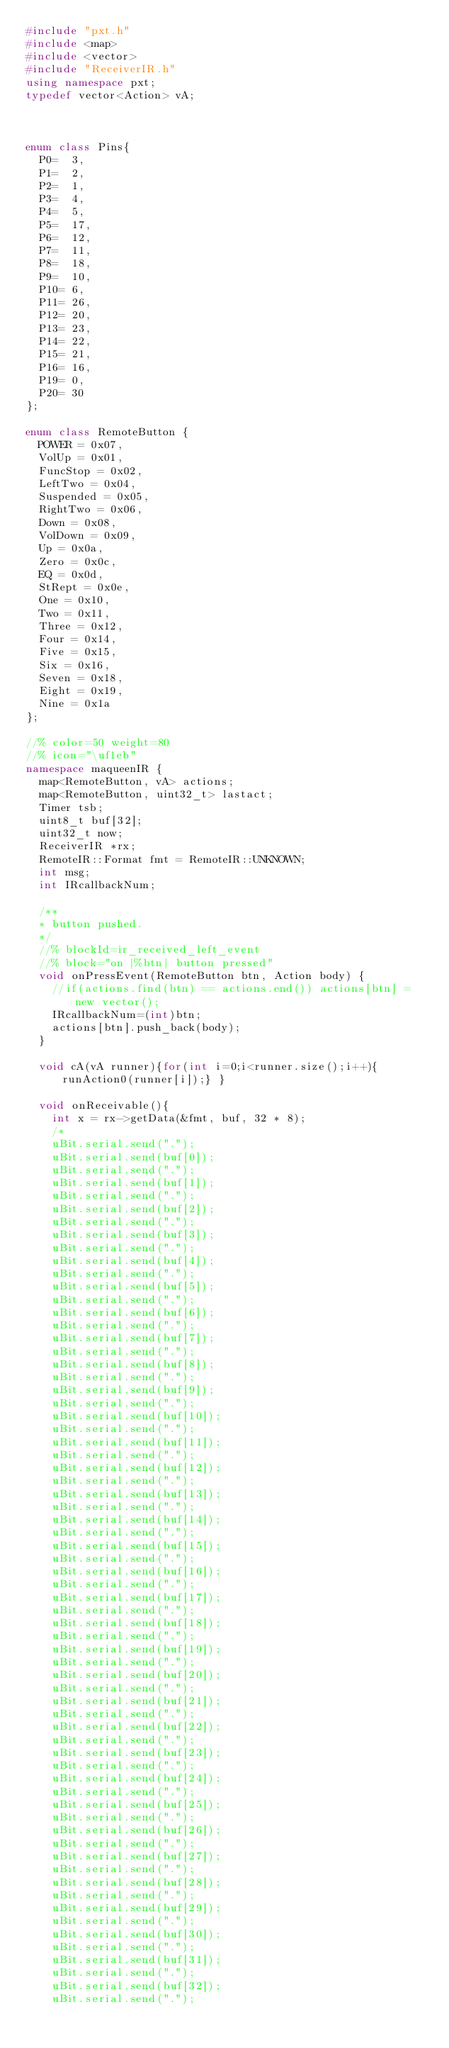<code> <loc_0><loc_0><loc_500><loc_500><_C++_>#include "pxt.h"
#include <map>
#include <vector>
#include "ReceiverIR.h"
using namespace pxt;
typedef vector<Action> vA;



enum class Pins{
  P0=  3,
  P1=  2,
  P2=  1,
  P3=  4,
  P4=  5,
  P5=  17,
  P6=  12,
  P7=  11,
  P8=  18,
  P9=  10,
  P10= 6,
  P11= 26,
  P12= 20,
  P13= 23,
  P14= 22,
  P15= 21,
  P16= 16,
  P19= 0,
  P20= 30
};

enum class RemoteButton {
  POWER = 0x07,
  VolUp = 0x01,
  FuncStop = 0x02,
  LeftTwo = 0x04,
  Suspended = 0x05,
  RightTwo = 0x06,
  Down = 0x08,
  VolDown = 0x09,
  Up = 0x0a,
  Zero = 0x0c,
  EQ = 0x0d,
  StRept = 0x0e,
  One = 0x10,
  Two = 0x11,
  Three = 0x12,
  Four = 0x14,
  Five = 0x15,
  Six = 0x16,
  Seven = 0x18,
  Eight = 0x19,
  Nine = 0x1a
};

//% color=50 weight=80
//% icon="\uf1eb"
namespace maqueenIR { 
  map<RemoteButton, vA> actions;
  map<RemoteButton, uint32_t> lastact;
  Timer tsb; 
  uint8_t buf[32];
  uint32_t now;
  ReceiverIR *rx;
  RemoteIR::Format fmt = RemoteIR::UNKNOWN;
  int msg;
  int IRcallbackNum;

  /**
  * button pushed.
  */
  //% blockId=ir_received_left_event
  //% block="on |%btn| button pressed"
  void onPressEvent(RemoteButton btn, Action body) {
    //if(actions.find(btn) == actions.end()) actions[btn] = new vector();
    IRcallbackNum=(int)btn;
    actions[btn].push_back(body);
  }

  void cA(vA runner){for(int i=0;i<runner.size();i++){runAction0(runner[i]);} }

  void onReceivable(){
    int x = rx->getData(&fmt, buf, 32 * 8);
    /*
    uBit.serial.send(".");
    uBit.serial.send(buf[0]);
    uBit.serial.send(".");
    uBit.serial.send(buf[1]);
    uBit.serial.send(".");
    uBit.serial.send(buf[2]);
    uBit.serial.send(".");
    uBit.serial.send(buf[3]);
    uBit.serial.send(".");
    uBit.serial.send(buf[4]);
    uBit.serial.send(".");
    uBit.serial.send(buf[5]);
    uBit.serial.send(".");
    uBit.serial.send(buf[6]);
    uBit.serial.send(".");
    uBit.serial.send(buf[7]);
    uBit.serial.send(".");
    uBit.serial.send(buf[8]);
    uBit.serial.send(".");
    uBit.serial.send(buf[9]);
    uBit.serial.send(".");
    uBit.serial.send(buf[10]);
    uBit.serial.send(".");
    uBit.serial.send(buf[11]);
    uBit.serial.send(".");
    uBit.serial.send(buf[12]);
    uBit.serial.send(".");
    uBit.serial.send(buf[13]);
    uBit.serial.send(".");
    uBit.serial.send(buf[14]);
    uBit.serial.send(".");
    uBit.serial.send(buf[15]);
    uBit.serial.send(".");
    uBit.serial.send(buf[16]);
    uBit.serial.send(".");
    uBit.serial.send(buf[17]);
    uBit.serial.send(".");
    uBit.serial.send(buf[18]);
    uBit.serial.send(".");
    uBit.serial.send(buf[19]);
    uBit.serial.send(".");
    uBit.serial.send(buf[20]);
    uBit.serial.send(".");
    uBit.serial.send(buf[21]);
    uBit.serial.send(".");
    uBit.serial.send(buf[22]);
    uBit.serial.send(".");
    uBit.serial.send(buf[23]);
    uBit.serial.send(".");
    uBit.serial.send(buf[24]);
    uBit.serial.send(".");
    uBit.serial.send(buf[25]);
    uBit.serial.send(".");
    uBit.serial.send(buf[26]);
    uBit.serial.send(".");
    uBit.serial.send(buf[27]);
    uBit.serial.send(".");
    uBit.serial.send(buf[28]);
    uBit.serial.send(".");
    uBit.serial.send(buf[29]);
    uBit.serial.send(".");
    uBit.serial.send(buf[30]);
    uBit.serial.send(".");
    uBit.serial.send(buf[31]);
    uBit.serial.send(".");
    uBit.serial.send(buf[32]);
    uBit.serial.send(".");</code> 